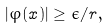Convert formula to latex. <formula><loc_0><loc_0><loc_500><loc_500>| \varphi ( x ) | \geq \epsilon / r ,</formula> 